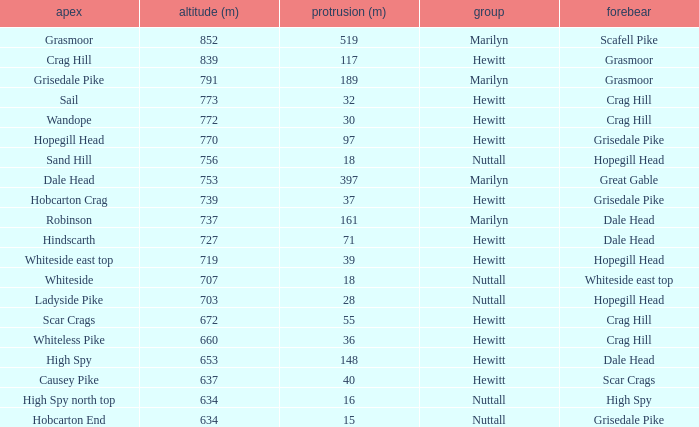Which Class is Peak Sail when it has a Prom larger than 30? Hewitt. Could you parse the entire table? {'header': ['apex', 'altitude (m)', 'protrusion (m)', 'group', 'forebear'], 'rows': [['Grasmoor', '852', '519', 'Marilyn', 'Scafell Pike'], ['Crag Hill', '839', '117', 'Hewitt', 'Grasmoor'], ['Grisedale Pike', '791', '189', 'Marilyn', 'Grasmoor'], ['Sail', '773', '32', 'Hewitt', 'Crag Hill'], ['Wandope', '772', '30', 'Hewitt', 'Crag Hill'], ['Hopegill Head', '770', '97', 'Hewitt', 'Grisedale Pike'], ['Sand Hill', '756', '18', 'Nuttall', 'Hopegill Head'], ['Dale Head', '753', '397', 'Marilyn', 'Great Gable'], ['Hobcarton Crag', '739', '37', 'Hewitt', 'Grisedale Pike'], ['Robinson', '737', '161', 'Marilyn', 'Dale Head'], ['Hindscarth', '727', '71', 'Hewitt', 'Dale Head'], ['Whiteside east top', '719', '39', 'Hewitt', 'Hopegill Head'], ['Whiteside', '707', '18', 'Nuttall', 'Whiteside east top'], ['Ladyside Pike', '703', '28', 'Nuttall', 'Hopegill Head'], ['Scar Crags', '672', '55', 'Hewitt', 'Crag Hill'], ['Whiteless Pike', '660', '36', 'Hewitt', 'Crag Hill'], ['High Spy', '653', '148', 'Hewitt', 'Dale Head'], ['Causey Pike', '637', '40', 'Hewitt', 'Scar Crags'], ['High Spy north top', '634', '16', 'Nuttall', 'High Spy'], ['Hobcarton End', '634', '15', 'Nuttall', 'Grisedale Pike']]} 